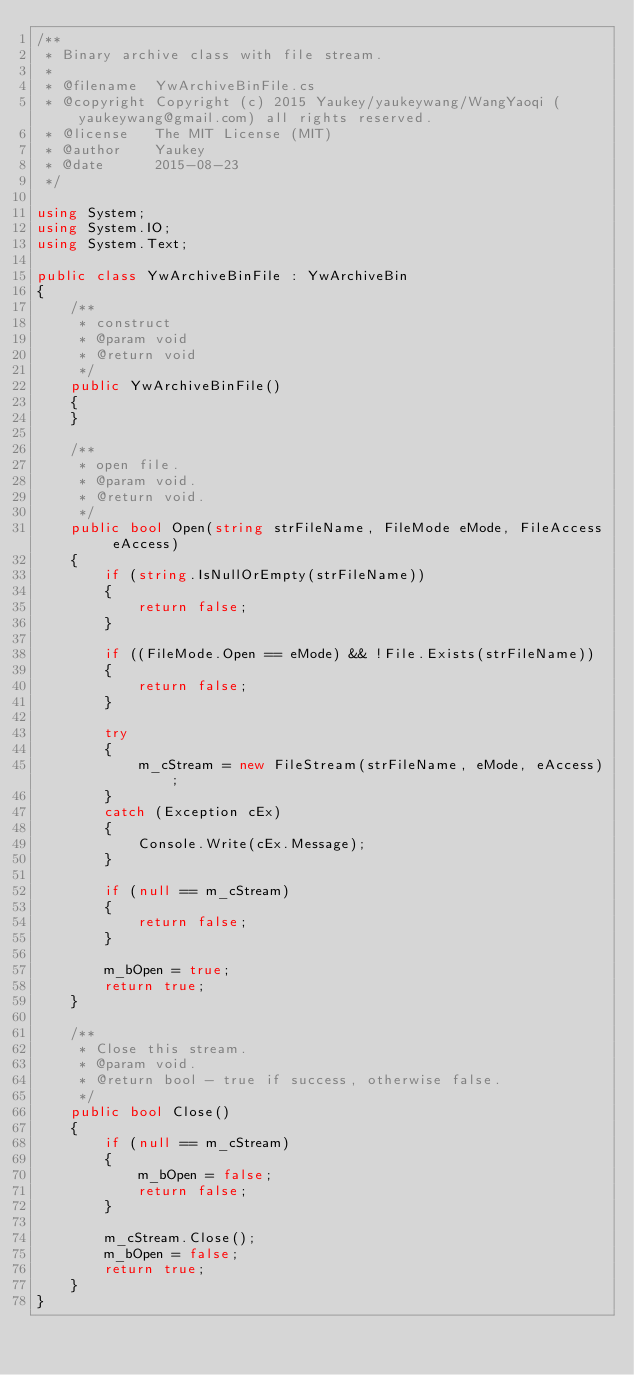<code> <loc_0><loc_0><loc_500><loc_500><_C#_>/**
 * Binary archive class with file stream.
 *
 * @filename  YwArchiveBinFile.cs
 * @copyright Copyright (c) 2015 Yaukey/yaukeywang/WangYaoqi (yaukeywang@gmail.com) all rights reserved.
 * @license   The MIT License (MIT)
 * @author    Yaukey
 * @date      2015-08-23
 */

using System;
using System.IO;
using System.Text;

public class YwArchiveBinFile : YwArchiveBin
{
	/**
     * construct
     * @param void
     * @return void
     */
	public YwArchiveBinFile()
	{
	}
	
	/**
     * open file.
     * @param void.
     * @return void.
     */
	public bool Open(string strFileName, FileMode eMode, FileAccess eAccess)
	{
		if (string.IsNullOrEmpty(strFileName))
		{
			return false;
		}
		
		if ((FileMode.Open == eMode) && !File.Exists(strFileName))
		{
			return false;
		}
		
		try
		{
			m_cStream = new FileStream(strFileName, eMode, eAccess);
		}
		catch (Exception cEx)
		{
			Console.Write(cEx.Message);
		}
		
		if (null == m_cStream)
		{
			return false;
		}
		
		m_bOpen = true;
		return true;
	}
	
	/**
     * Close this stream.
     * @param void.
     * @return bool - true if success, otherwise false.
     */
	public bool Close()
	{
		if (null == m_cStream)
		{
			m_bOpen = false;
			return false;
		}
		
		m_cStream.Close();
		m_bOpen = false;
		return true;
	}
}
</code> 